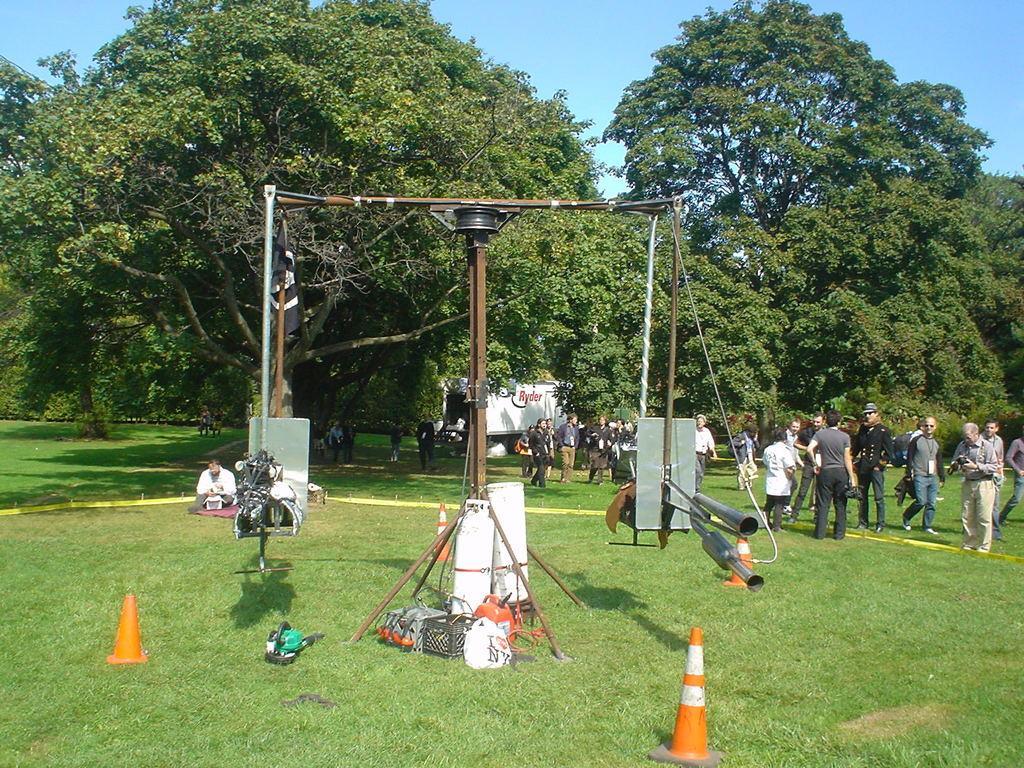Please provide a concise description of this image. As we can see in the image there are traffic cones, few people and trees. There is a building, grass and at the top there is sky. 